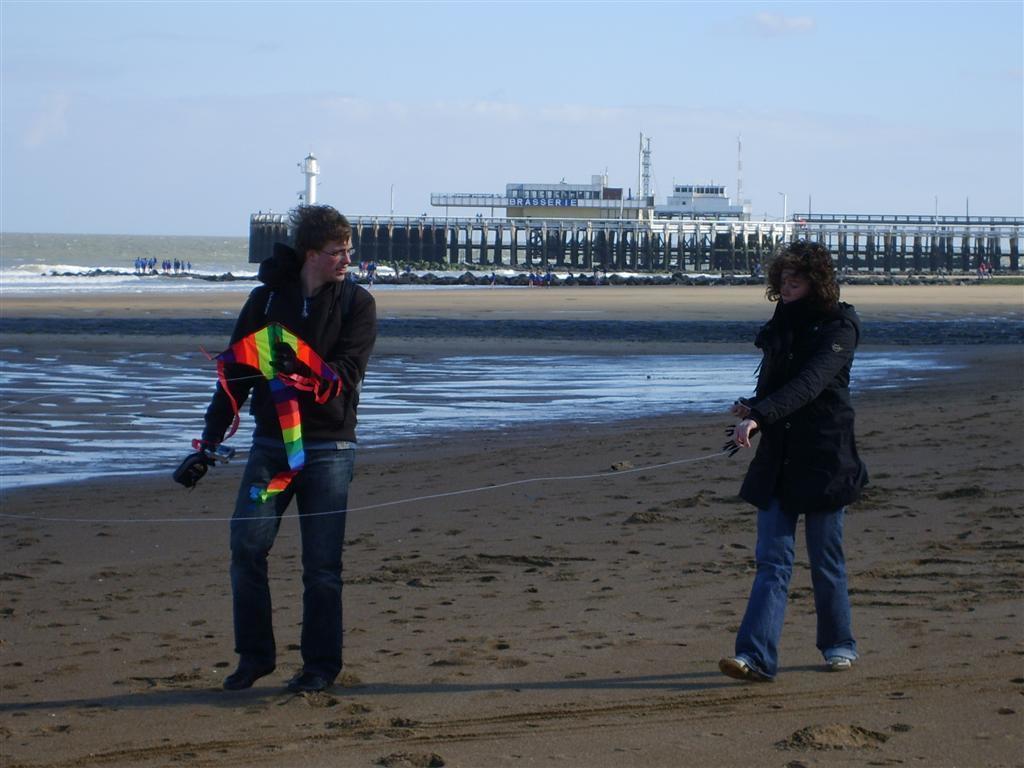Please provide a concise description of this image. In this image we can see two persons walking on the ground, one of them is holding a kite, behind them there is a bridge, a lighthouse, buildings, and a pole, also we can see the ocean and the sky. 